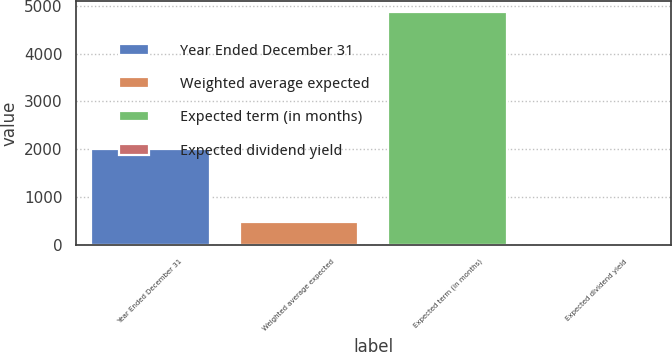Convert chart to OTSL. <chart><loc_0><loc_0><loc_500><loc_500><bar_chart><fcel>Year Ended December 31<fcel>Weighted average expected<fcel>Expected term (in months)<fcel>Expected dividend yield<nl><fcel>2006<fcel>487.15<fcel>4858<fcel>1.5<nl></chart> 